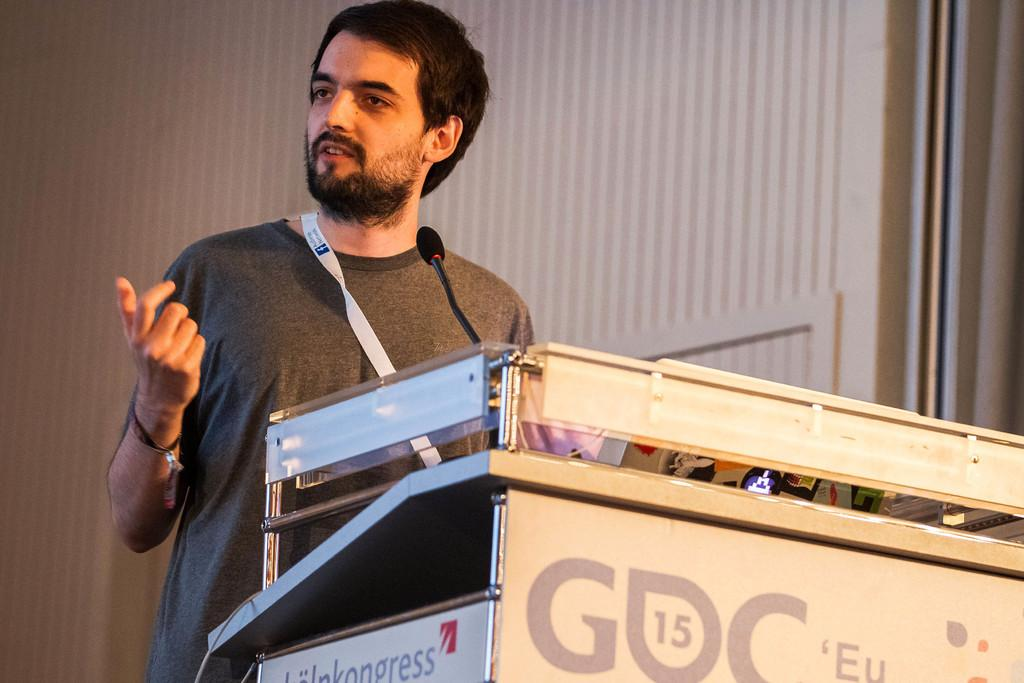Who is the main subject in the image? There is a man in the image. What is the man doing in the image? The man is giving a seminar. What object is in front of the man? There is a microphone in front of the man. What is the man wearing around his shoulder? The man is wearing a tag around his shoulder. What type of steam is coming out of the man's mouth during the seminar? There is no steam coming out of the man's mouth during the seminar, as the image does not depict any steam. 